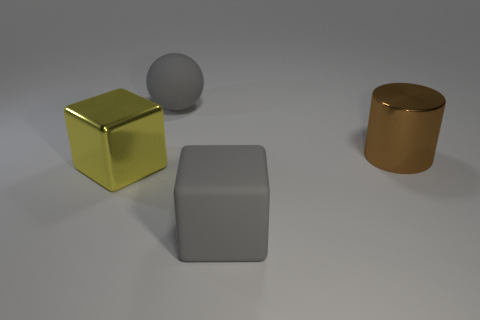Add 3 large yellow objects. How many objects exist? 7 Subtract all balls. How many objects are left? 3 Subtract 0 yellow balls. How many objects are left? 4 Subtract all cylinders. Subtract all large gray blocks. How many objects are left? 2 Add 3 shiny cylinders. How many shiny cylinders are left? 4 Add 2 rubber cubes. How many rubber cubes exist? 3 